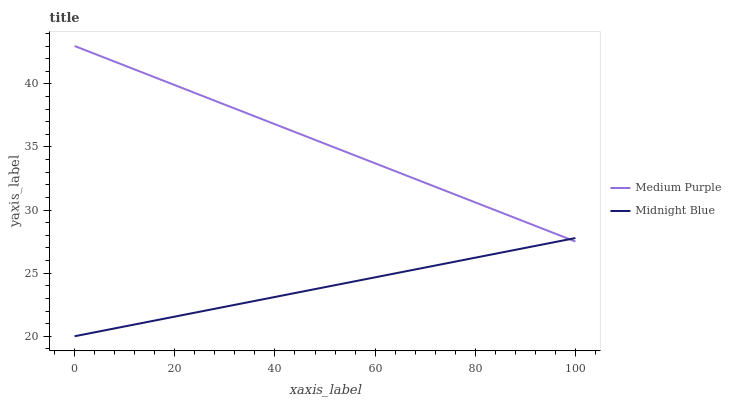Does Midnight Blue have the minimum area under the curve?
Answer yes or no. Yes. Does Medium Purple have the maximum area under the curve?
Answer yes or no. Yes. Does Midnight Blue have the maximum area under the curve?
Answer yes or no. No. Is Midnight Blue the smoothest?
Answer yes or no. Yes. Is Medium Purple the roughest?
Answer yes or no. Yes. Is Midnight Blue the roughest?
Answer yes or no. No. Does Midnight Blue have the lowest value?
Answer yes or no. Yes. Does Medium Purple have the highest value?
Answer yes or no. Yes. Does Midnight Blue have the highest value?
Answer yes or no. No. Does Medium Purple intersect Midnight Blue?
Answer yes or no. Yes. Is Medium Purple less than Midnight Blue?
Answer yes or no. No. Is Medium Purple greater than Midnight Blue?
Answer yes or no. No. 